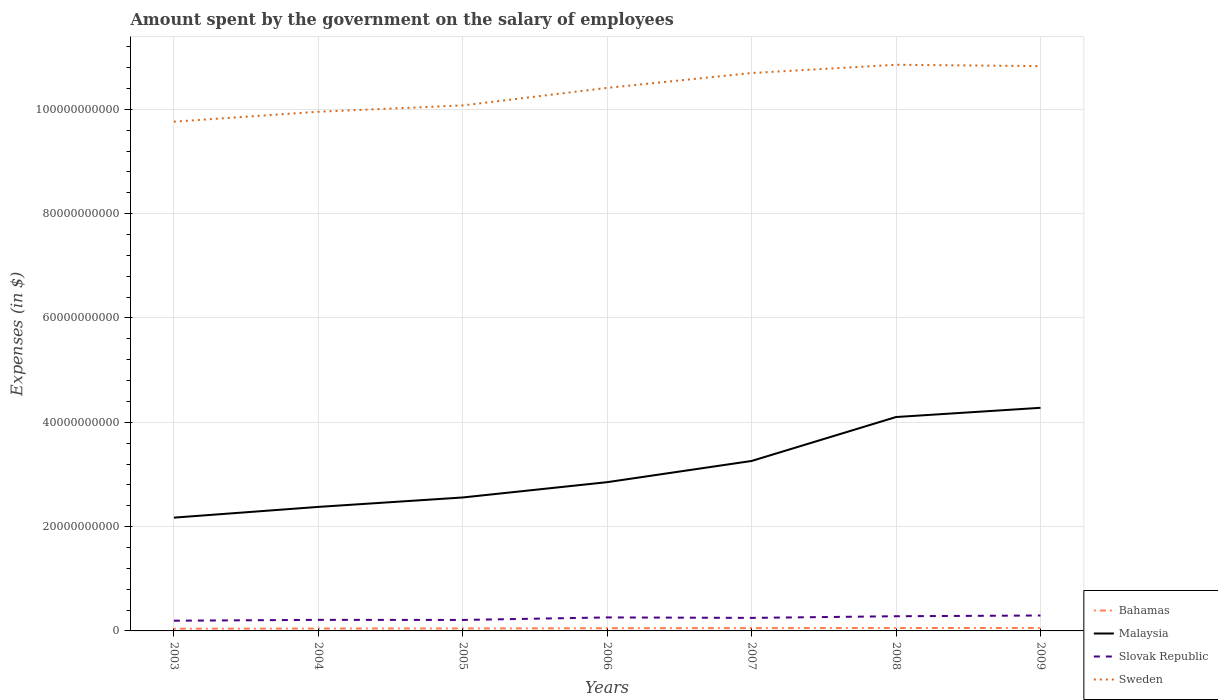How many different coloured lines are there?
Offer a terse response. 4. Does the line corresponding to Malaysia intersect with the line corresponding to Bahamas?
Your response must be concise. No. Is the number of lines equal to the number of legend labels?
Your answer should be very brief. Yes. Across all years, what is the maximum amount spent on the salary of employees by the government in Malaysia?
Keep it short and to the point. 2.17e+1. In which year was the amount spent on the salary of employees by the government in Slovak Republic maximum?
Provide a succinct answer. 2003. What is the total amount spent on the salary of employees by the government in Bahamas in the graph?
Offer a terse response. -2.32e+07. What is the difference between the highest and the second highest amount spent on the salary of employees by the government in Slovak Republic?
Provide a succinct answer. 9.97e+08. What is the difference between the highest and the lowest amount spent on the salary of employees by the government in Malaysia?
Your response must be concise. 3. How many lines are there?
Your answer should be very brief. 4. How many years are there in the graph?
Ensure brevity in your answer.  7. Does the graph contain any zero values?
Offer a very short reply. No. What is the title of the graph?
Offer a terse response. Amount spent by the government on the salary of employees. What is the label or title of the Y-axis?
Your response must be concise. Expenses (in $). What is the Expenses (in $) of Bahamas in 2003?
Give a very brief answer. 4.21e+08. What is the Expenses (in $) in Malaysia in 2003?
Offer a very short reply. 2.17e+1. What is the Expenses (in $) of Slovak Republic in 2003?
Ensure brevity in your answer.  1.96e+09. What is the Expenses (in $) of Sweden in 2003?
Give a very brief answer. 9.76e+1. What is the Expenses (in $) in Bahamas in 2004?
Offer a very short reply. 4.50e+08. What is the Expenses (in $) in Malaysia in 2004?
Offer a terse response. 2.38e+1. What is the Expenses (in $) of Slovak Republic in 2004?
Provide a succinct answer. 2.12e+09. What is the Expenses (in $) of Sweden in 2004?
Your answer should be very brief. 9.95e+1. What is the Expenses (in $) of Bahamas in 2005?
Your answer should be very brief. 4.70e+08. What is the Expenses (in $) in Malaysia in 2005?
Give a very brief answer. 2.56e+1. What is the Expenses (in $) of Slovak Republic in 2005?
Give a very brief answer. 2.10e+09. What is the Expenses (in $) in Sweden in 2005?
Your answer should be very brief. 1.01e+11. What is the Expenses (in $) of Bahamas in 2006?
Ensure brevity in your answer.  5.14e+08. What is the Expenses (in $) in Malaysia in 2006?
Offer a very short reply. 2.85e+1. What is the Expenses (in $) of Slovak Republic in 2006?
Provide a succinct answer. 2.59e+09. What is the Expenses (in $) in Sweden in 2006?
Keep it short and to the point. 1.04e+11. What is the Expenses (in $) in Bahamas in 2007?
Your answer should be very brief. 5.37e+08. What is the Expenses (in $) in Malaysia in 2007?
Provide a succinct answer. 3.26e+1. What is the Expenses (in $) in Slovak Republic in 2007?
Your answer should be compact. 2.50e+09. What is the Expenses (in $) in Sweden in 2007?
Make the answer very short. 1.07e+11. What is the Expenses (in $) in Bahamas in 2008?
Provide a succinct answer. 5.52e+08. What is the Expenses (in $) in Malaysia in 2008?
Make the answer very short. 4.10e+1. What is the Expenses (in $) in Slovak Republic in 2008?
Offer a terse response. 2.82e+09. What is the Expenses (in $) in Sweden in 2008?
Your response must be concise. 1.09e+11. What is the Expenses (in $) in Bahamas in 2009?
Give a very brief answer. 5.73e+08. What is the Expenses (in $) of Malaysia in 2009?
Offer a very short reply. 4.28e+1. What is the Expenses (in $) of Slovak Republic in 2009?
Make the answer very short. 2.96e+09. What is the Expenses (in $) in Sweden in 2009?
Ensure brevity in your answer.  1.08e+11. Across all years, what is the maximum Expenses (in $) in Bahamas?
Offer a very short reply. 5.73e+08. Across all years, what is the maximum Expenses (in $) of Malaysia?
Your answer should be compact. 4.28e+1. Across all years, what is the maximum Expenses (in $) in Slovak Republic?
Give a very brief answer. 2.96e+09. Across all years, what is the maximum Expenses (in $) of Sweden?
Offer a very short reply. 1.09e+11. Across all years, what is the minimum Expenses (in $) in Bahamas?
Ensure brevity in your answer.  4.21e+08. Across all years, what is the minimum Expenses (in $) of Malaysia?
Ensure brevity in your answer.  2.17e+1. Across all years, what is the minimum Expenses (in $) of Slovak Republic?
Provide a succinct answer. 1.96e+09. Across all years, what is the minimum Expenses (in $) of Sweden?
Offer a very short reply. 9.76e+1. What is the total Expenses (in $) of Bahamas in the graph?
Provide a short and direct response. 3.52e+09. What is the total Expenses (in $) in Malaysia in the graph?
Your answer should be very brief. 2.16e+11. What is the total Expenses (in $) in Slovak Republic in the graph?
Provide a succinct answer. 1.70e+1. What is the total Expenses (in $) in Sweden in the graph?
Make the answer very short. 7.26e+11. What is the difference between the Expenses (in $) of Bahamas in 2003 and that in 2004?
Provide a succinct answer. -2.88e+07. What is the difference between the Expenses (in $) in Malaysia in 2003 and that in 2004?
Offer a very short reply. -2.06e+09. What is the difference between the Expenses (in $) of Slovak Republic in 2003 and that in 2004?
Offer a terse response. -1.66e+08. What is the difference between the Expenses (in $) of Sweden in 2003 and that in 2004?
Keep it short and to the point. -1.91e+09. What is the difference between the Expenses (in $) in Bahamas in 2003 and that in 2005?
Provide a short and direct response. -4.88e+07. What is the difference between the Expenses (in $) in Malaysia in 2003 and that in 2005?
Provide a succinct answer. -3.87e+09. What is the difference between the Expenses (in $) of Slovak Republic in 2003 and that in 2005?
Give a very brief answer. -1.46e+08. What is the difference between the Expenses (in $) in Sweden in 2003 and that in 2005?
Make the answer very short. -3.12e+09. What is the difference between the Expenses (in $) of Bahamas in 2003 and that in 2006?
Give a very brief answer. -9.22e+07. What is the difference between the Expenses (in $) of Malaysia in 2003 and that in 2006?
Your response must be concise. -6.80e+09. What is the difference between the Expenses (in $) in Slovak Republic in 2003 and that in 2006?
Keep it short and to the point. -6.29e+08. What is the difference between the Expenses (in $) of Sweden in 2003 and that in 2006?
Your answer should be very brief. -6.48e+09. What is the difference between the Expenses (in $) of Bahamas in 2003 and that in 2007?
Offer a terse response. -1.15e+08. What is the difference between the Expenses (in $) in Malaysia in 2003 and that in 2007?
Offer a very short reply. -1.09e+1. What is the difference between the Expenses (in $) in Slovak Republic in 2003 and that in 2007?
Give a very brief answer. -5.42e+08. What is the difference between the Expenses (in $) in Sweden in 2003 and that in 2007?
Your answer should be very brief. -9.33e+09. What is the difference between the Expenses (in $) in Bahamas in 2003 and that in 2008?
Ensure brevity in your answer.  -1.31e+08. What is the difference between the Expenses (in $) in Malaysia in 2003 and that in 2008?
Provide a succinct answer. -1.93e+1. What is the difference between the Expenses (in $) in Slovak Republic in 2003 and that in 2008?
Provide a short and direct response. -8.58e+08. What is the difference between the Expenses (in $) in Sweden in 2003 and that in 2008?
Provide a succinct answer. -1.09e+1. What is the difference between the Expenses (in $) in Bahamas in 2003 and that in 2009?
Provide a succinct answer. -1.52e+08. What is the difference between the Expenses (in $) in Malaysia in 2003 and that in 2009?
Your answer should be very brief. -2.11e+1. What is the difference between the Expenses (in $) of Slovak Republic in 2003 and that in 2009?
Offer a terse response. -9.97e+08. What is the difference between the Expenses (in $) of Sweden in 2003 and that in 2009?
Provide a short and direct response. -1.06e+1. What is the difference between the Expenses (in $) of Bahamas in 2004 and that in 2005?
Offer a terse response. -2.00e+07. What is the difference between the Expenses (in $) in Malaysia in 2004 and that in 2005?
Provide a succinct answer. -1.81e+09. What is the difference between the Expenses (in $) in Slovak Republic in 2004 and that in 2005?
Your answer should be compact. 1.95e+07. What is the difference between the Expenses (in $) in Sweden in 2004 and that in 2005?
Offer a very short reply. -1.21e+09. What is the difference between the Expenses (in $) of Bahamas in 2004 and that in 2006?
Give a very brief answer. -6.34e+07. What is the difference between the Expenses (in $) of Malaysia in 2004 and that in 2006?
Give a very brief answer. -4.74e+09. What is the difference between the Expenses (in $) of Slovak Republic in 2004 and that in 2006?
Your response must be concise. -4.64e+08. What is the difference between the Expenses (in $) of Sweden in 2004 and that in 2006?
Make the answer very short. -4.57e+09. What is the difference between the Expenses (in $) of Bahamas in 2004 and that in 2007?
Ensure brevity in your answer.  -8.66e+07. What is the difference between the Expenses (in $) of Malaysia in 2004 and that in 2007?
Provide a short and direct response. -8.81e+09. What is the difference between the Expenses (in $) of Slovak Republic in 2004 and that in 2007?
Provide a short and direct response. -3.76e+08. What is the difference between the Expenses (in $) of Sweden in 2004 and that in 2007?
Your response must be concise. -7.42e+09. What is the difference between the Expenses (in $) of Bahamas in 2004 and that in 2008?
Make the answer very short. -1.02e+08. What is the difference between the Expenses (in $) of Malaysia in 2004 and that in 2008?
Your answer should be very brief. -1.72e+1. What is the difference between the Expenses (in $) of Slovak Republic in 2004 and that in 2008?
Make the answer very short. -6.92e+08. What is the difference between the Expenses (in $) in Sweden in 2004 and that in 2008?
Offer a terse response. -9.00e+09. What is the difference between the Expenses (in $) of Bahamas in 2004 and that in 2009?
Your answer should be very brief. -1.23e+08. What is the difference between the Expenses (in $) of Malaysia in 2004 and that in 2009?
Your answer should be compact. -1.90e+1. What is the difference between the Expenses (in $) of Slovak Republic in 2004 and that in 2009?
Ensure brevity in your answer.  -8.31e+08. What is the difference between the Expenses (in $) of Sweden in 2004 and that in 2009?
Offer a terse response. -8.74e+09. What is the difference between the Expenses (in $) of Bahamas in 2005 and that in 2006?
Your answer should be very brief. -4.34e+07. What is the difference between the Expenses (in $) in Malaysia in 2005 and that in 2006?
Provide a short and direct response. -2.93e+09. What is the difference between the Expenses (in $) in Slovak Republic in 2005 and that in 2006?
Give a very brief answer. -4.83e+08. What is the difference between the Expenses (in $) in Sweden in 2005 and that in 2006?
Provide a succinct answer. -3.36e+09. What is the difference between the Expenses (in $) in Bahamas in 2005 and that in 2007?
Your answer should be very brief. -6.66e+07. What is the difference between the Expenses (in $) in Malaysia in 2005 and that in 2007?
Give a very brief answer. -7.00e+09. What is the difference between the Expenses (in $) in Slovak Republic in 2005 and that in 2007?
Provide a succinct answer. -3.95e+08. What is the difference between the Expenses (in $) of Sweden in 2005 and that in 2007?
Keep it short and to the point. -6.21e+09. What is the difference between the Expenses (in $) of Bahamas in 2005 and that in 2008?
Your answer should be very brief. -8.19e+07. What is the difference between the Expenses (in $) in Malaysia in 2005 and that in 2008?
Give a very brief answer. -1.54e+1. What is the difference between the Expenses (in $) in Slovak Republic in 2005 and that in 2008?
Make the answer very short. -7.11e+08. What is the difference between the Expenses (in $) in Sweden in 2005 and that in 2008?
Provide a succinct answer. -7.79e+09. What is the difference between the Expenses (in $) in Bahamas in 2005 and that in 2009?
Your answer should be very brief. -1.03e+08. What is the difference between the Expenses (in $) of Malaysia in 2005 and that in 2009?
Offer a very short reply. -1.72e+1. What is the difference between the Expenses (in $) in Slovak Republic in 2005 and that in 2009?
Your response must be concise. -8.51e+08. What is the difference between the Expenses (in $) of Sweden in 2005 and that in 2009?
Your answer should be compact. -7.53e+09. What is the difference between the Expenses (in $) in Bahamas in 2006 and that in 2007?
Your response must be concise. -2.32e+07. What is the difference between the Expenses (in $) of Malaysia in 2006 and that in 2007?
Provide a short and direct response. -4.07e+09. What is the difference between the Expenses (in $) of Slovak Republic in 2006 and that in 2007?
Your response must be concise. 8.77e+07. What is the difference between the Expenses (in $) of Sweden in 2006 and that in 2007?
Provide a short and direct response. -2.85e+09. What is the difference between the Expenses (in $) in Bahamas in 2006 and that in 2008?
Your answer should be compact. -3.85e+07. What is the difference between the Expenses (in $) of Malaysia in 2006 and that in 2008?
Keep it short and to the point. -1.25e+1. What is the difference between the Expenses (in $) of Slovak Republic in 2006 and that in 2008?
Ensure brevity in your answer.  -2.28e+08. What is the difference between the Expenses (in $) in Sweden in 2006 and that in 2008?
Your answer should be compact. -4.43e+09. What is the difference between the Expenses (in $) in Bahamas in 2006 and that in 2009?
Provide a short and direct response. -5.96e+07. What is the difference between the Expenses (in $) of Malaysia in 2006 and that in 2009?
Provide a short and direct response. -1.43e+1. What is the difference between the Expenses (in $) of Slovak Republic in 2006 and that in 2009?
Keep it short and to the point. -3.68e+08. What is the difference between the Expenses (in $) of Sweden in 2006 and that in 2009?
Provide a short and direct response. -4.17e+09. What is the difference between the Expenses (in $) in Bahamas in 2007 and that in 2008?
Your response must be concise. -1.53e+07. What is the difference between the Expenses (in $) of Malaysia in 2007 and that in 2008?
Give a very brief answer. -8.42e+09. What is the difference between the Expenses (in $) in Slovak Republic in 2007 and that in 2008?
Your answer should be compact. -3.16e+08. What is the difference between the Expenses (in $) in Sweden in 2007 and that in 2008?
Provide a short and direct response. -1.58e+09. What is the difference between the Expenses (in $) in Bahamas in 2007 and that in 2009?
Provide a succinct answer. -3.64e+07. What is the difference between the Expenses (in $) of Malaysia in 2007 and that in 2009?
Your response must be concise. -1.02e+1. What is the difference between the Expenses (in $) in Slovak Republic in 2007 and that in 2009?
Your answer should be very brief. -4.55e+08. What is the difference between the Expenses (in $) of Sweden in 2007 and that in 2009?
Give a very brief answer. -1.32e+09. What is the difference between the Expenses (in $) in Bahamas in 2008 and that in 2009?
Ensure brevity in your answer.  -2.11e+07. What is the difference between the Expenses (in $) of Malaysia in 2008 and that in 2009?
Make the answer very short. -1.77e+09. What is the difference between the Expenses (in $) of Slovak Republic in 2008 and that in 2009?
Your response must be concise. -1.39e+08. What is the difference between the Expenses (in $) of Sweden in 2008 and that in 2009?
Ensure brevity in your answer.  2.59e+08. What is the difference between the Expenses (in $) of Bahamas in 2003 and the Expenses (in $) of Malaysia in 2004?
Ensure brevity in your answer.  -2.34e+1. What is the difference between the Expenses (in $) of Bahamas in 2003 and the Expenses (in $) of Slovak Republic in 2004?
Offer a very short reply. -1.70e+09. What is the difference between the Expenses (in $) in Bahamas in 2003 and the Expenses (in $) in Sweden in 2004?
Offer a very short reply. -9.91e+1. What is the difference between the Expenses (in $) in Malaysia in 2003 and the Expenses (in $) in Slovak Republic in 2004?
Ensure brevity in your answer.  1.96e+1. What is the difference between the Expenses (in $) of Malaysia in 2003 and the Expenses (in $) of Sweden in 2004?
Your answer should be very brief. -7.78e+1. What is the difference between the Expenses (in $) in Slovak Republic in 2003 and the Expenses (in $) in Sweden in 2004?
Ensure brevity in your answer.  -9.76e+1. What is the difference between the Expenses (in $) of Bahamas in 2003 and the Expenses (in $) of Malaysia in 2005?
Keep it short and to the point. -2.52e+1. What is the difference between the Expenses (in $) of Bahamas in 2003 and the Expenses (in $) of Slovak Republic in 2005?
Your response must be concise. -1.68e+09. What is the difference between the Expenses (in $) in Bahamas in 2003 and the Expenses (in $) in Sweden in 2005?
Provide a short and direct response. -1.00e+11. What is the difference between the Expenses (in $) in Malaysia in 2003 and the Expenses (in $) in Slovak Republic in 2005?
Keep it short and to the point. 1.96e+1. What is the difference between the Expenses (in $) of Malaysia in 2003 and the Expenses (in $) of Sweden in 2005?
Offer a terse response. -7.90e+1. What is the difference between the Expenses (in $) of Slovak Republic in 2003 and the Expenses (in $) of Sweden in 2005?
Offer a very short reply. -9.88e+1. What is the difference between the Expenses (in $) in Bahamas in 2003 and the Expenses (in $) in Malaysia in 2006?
Provide a succinct answer. -2.81e+1. What is the difference between the Expenses (in $) of Bahamas in 2003 and the Expenses (in $) of Slovak Republic in 2006?
Ensure brevity in your answer.  -2.17e+09. What is the difference between the Expenses (in $) of Bahamas in 2003 and the Expenses (in $) of Sweden in 2006?
Keep it short and to the point. -1.04e+11. What is the difference between the Expenses (in $) in Malaysia in 2003 and the Expenses (in $) in Slovak Republic in 2006?
Your answer should be very brief. 1.91e+1. What is the difference between the Expenses (in $) of Malaysia in 2003 and the Expenses (in $) of Sweden in 2006?
Offer a terse response. -8.24e+1. What is the difference between the Expenses (in $) of Slovak Republic in 2003 and the Expenses (in $) of Sweden in 2006?
Your answer should be compact. -1.02e+11. What is the difference between the Expenses (in $) in Bahamas in 2003 and the Expenses (in $) in Malaysia in 2007?
Offer a terse response. -3.22e+1. What is the difference between the Expenses (in $) in Bahamas in 2003 and the Expenses (in $) in Slovak Republic in 2007?
Offer a terse response. -2.08e+09. What is the difference between the Expenses (in $) of Bahamas in 2003 and the Expenses (in $) of Sweden in 2007?
Your answer should be compact. -1.07e+11. What is the difference between the Expenses (in $) of Malaysia in 2003 and the Expenses (in $) of Slovak Republic in 2007?
Provide a short and direct response. 1.92e+1. What is the difference between the Expenses (in $) of Malaysia in 2003 and the Expenses (in $) of Sweden in 2007?
Your answer should be compact. -8.52e+1. What is the difference between the Expenses (in $) of Slovak Republic in 2003 and the Expenses (in $) of Sweden in 2007?
Your answer should be compact. -1.05e+11. What is the difference between the Expenses (in $) in Bahamas in 2003 and the Expenses (in $) in Malaysia in 2008?
Make the answer very short. -4.06e+1. What is the difference between the Expenses (in $) in Bahamas in 2003 and the Expenses (in $) in Slovak Republic in 2008?
Your answer should be compact. -2.39e+09. What is the difference between the Expenses (in $) of Bahamas in 2003 and the Expenses (in $) of Sweden in 2008?
Keep it short and to the point. -1.08e+11. What is the difference between the Expenses (in $) of Malaysia in 2003 and the Expenses (in $) of Slovak Republic in 2008?
Your answer should be very brief. 1.89e+1. What is the difference between the Expenses (in $) of Malaysia in 2003 and the Expenses (in $) of Sweden in 2008?
Keep it short and to the point. -8.68e+1. What is the difference between the Expenses (in $) of Slovak Republic in 2003 and the Expenses (in $) of Sweden in 2008?
Your answer should be compact. -1.07e+11. What is the difference between the Expenses (in $) in Bahamas in 2003 and the Expenses (in $) in Malaysia in 2009?
Your answer should be very brief. -4.24e+1. What is the difference between the Expenses (in $) in Bahamas in 2003 and the Expenses (in $) in Slovak Republic in 2009?
Provide a succinct answer. -2.53e+09. What is the difference between the Expenses (in $) in Bahamas in 2003 and the Expenses (in $) in Sweden in 2009?
Offer a terse response. -1.08e+11. What is the difference between the Expenses (in $) of Malaysia in 2003 and the Expenses (in $) of Slovak Republic in 2009?
Make the answer very short. 1.88e+1. What is the difference between the Expenses (in $) in Malaysia in 2003 and the Expenses (in $) in Sweden in 2009?
Give a very brief answer. -8.66e+1. What is the difference between the Expenses (in $) in Slovak Republic in 2003 and the Expenses (in $) in Sweden in 2009?
Your answer should be very brief. -1.06e+11. What is the difference between the Expenses (in $) in Bahamas in 2004 and the Expenses (in $) in Malaysia in 2005?
Your answer should be compact. -2.51e+1. What is the difference between the Expenses (in $) in Bahamas in 2004 and the Expenses (in $) in Slovak Republic in 2005?
Give a very brief answer. -1.65e+09. What is the difference between the Expenses (in $) in Bahamas in 2004 and the Expenses (in $) in Sweden in 2005?
Make the answer very short. -1.00e+11. What is the difference between the Expenses (in $) of Malaysia in 2004 and the Expenses (in $) of Slovak Republic in 2005?
Your answer should be compact. 2.17e+1. What is the difference between the Expenses (in $) of Malaysia in 2004 and the Expenses (in $) of Sweden in 2005?
Offer a terse response. -7.70e+1. What is the difference between the Expenses (in $) of Slovak Republic in 2004 and the Expenses (in $) of Sweden in 2005?
Give a very brief answer. -9.86e+1. What is the difference between the Expenses (in $) in Bahamas in 2004 and the Expenses (in $) in Malaysia in 2006?
Offer a very short reply. -2.81e+1. What is the difference between the Expenses (in $) of Bahamas in 2004 and the Expenses (in $) of Slovak Republic in 2006?
Your answer should be compact. -2.14e+09. What is the difference between the Expenses (in $) in Bahamas in 2004 and the Expenses (in $) in Sweden in 2006?
Provide a succinct answer. -1.04e+11. What is the difference between the Expenses (in $) of Malaysia in 2004 and the Expenses (in $) of Slovak Republic in 2006?
Your answer should be compact. 2.12e+1. What is the difference between the Expenses (in $) in Malaysia in 2004 and the Expenses (in $) in Sweden in 2006?
Offer a very short reply. -8.03e+1. What is the difference between the Expenses (in $) of Slovak Republic in 2004 and the Expenses (in $) of Sweden in 2006?
Offer a terse response. -1.02e+11. What is the difference between the Expenses (in $) of Bahamas in 2004 and the Expenses (in $) of Malaysia in 2007?
Provide a succinct answer. -3.21e+1. What is the difference between the Expenses (in $) in Bahamas in 2004 and the Expenses (in $) in Slovak Republic in 2007?
Offer a very short reply. -2.05e+09. What is the difference between the Expenses (in $) in Bahamas in 2004 and the Expenses (in $) in Sweden in 2007?
Your answer should be very brief. -1.07e+11. What is the difference between the Expenses (in $) of Malaysia in 2004 and the Expenses (in $) of Slovak Republic in 2007?
Your answer should be compact. 2.13e+1. What is the difference between the Expenses (in $) of Malaysia in 2004 and the Expenses (in $) of Sweden in 2007?
Ensure brevity in your answer.  -8.32e+1. What is the difference between the Expenses (in $) of Slovak Republic in 2004 and the Expenses (in $) of Sweden in 2007?
Your answer should be very brief. -1.05e+11. What is the difference between the Expenses (in $) in Bahamas in 2004 and the Expenses (in $) in Malaysia in 2008?
Give a very brief answer. -4.06e+1. What is the difference between the Expenses (in $) of Bahamas in 2004 and the Expenses (in $) of Slovak Republic in 2008?
Provide a succinct answer. -2.37e+09. What is the difference between the Expenses (in $) of Bahamas in 2004 and the Expenses (in $) of Sweden in 2008?
Provide a short and direct response. -1.08e+11. What is the difference between the Expenses (in $) in Malaysia in 2004 and the Expenses (in $) in Slovak Republic in 2008?
Give a very brief answer. 2.10e+1. What is the difference between the Expenses (in $) in Malaysia in 2004 and the Expenses (in $) in Sweden in 2008?
Ensure brevity in your answer.  -8.48e+1. What is the difference between the Expenses (in $) in Slovak Republic in 2004 and the Expenses (in $) in Sweden in 2008?
Your response must be concise. -1.06e+11. What is the difference between the Expenses (in $) in Bahamas in 2004 and the Expenses (in $) in Malaysia in 2009?
Give a very brief answer. -4.23e+1. What is the difference between the Expenses (in $) of Bahamas in 2004 and the Expenses (in $) of Slovak Republic in 2009?
Your answer should be very brief. -2.50e+09. What is the difference between the Expenses (in $) in Bahamas in 2004 and the Expenses (in $) in Sweden in 2009?
Your response must be concise. -1.08e+11. What is the difference between the Expenses (in $) in Malaysia in 2004 and the Expenses (in $) in Slovak Republic in 2009?
Offer a terse response. 2.08e+1. What is the difference between the Expenses (in $) in Malaysia in 2004 and the Expenses (in $) in Sweden in 2009?
Your response must be concise. -8.45e+1. What is the difference between the Expenses (in $) of Slovak Republic in 2004 and the Expenses (in $) of Sweden in 2009?
Your response must be concise. -1.06e+11. What is the difference between the Expenses (in $) in Bahamas in 2005 and the Expenses (in $) in Malaysia in 2006?
Offer a terse response. -2.81e+1. What is the difference between the Expenses (in $) of Bahamas in 2005 and the Expenses (in $) of Slovak Republic in 2006?
Provide a succinct answer. -2.12e+09. What is the difference between the Expenses (in $) in Bahamas in 2005 and the Expenses (in $) in Sweden in 2006?
Offer a terse response. -1.04e+11. What is the difference between the Expenses (in $) in Malaysia in 2005 and the Expenses (in $) in Slovak Republic in 2006?
Your answer should be very brief. 2.30e+1. What is the difference between the Expenses (in $) of Malaysia in 2005 and the Expenses (in $) of Sweden in 2006?
Your answer should be very brief. -7.85e+1. What is the difference between the Expenses (in $) in Slovak Republic in 2005 and the Expenses (in $) in Sweden in 2006?
Your answer should be compact. -1.02e+11. What is the difference between the Expenses (in $) in Bahamas in 2005 and the Expenses (in $) in Malaysia in 2007?
Keep it short and to the point. -3.21e+1. What is the difference between the Expenses (in $) in Bahamas in 2005 and the Expenses (in $) in Slovak Republic in 2007?
Provide a succinct answer. -2.03e+09. What is the difference between the Expenses (in $) of Bahamas in 2005 and the Expenses (in $) of Sweden in 2007?
Your answer should be very brief. -1.06e+11. What is the difference between the Expenses (in $) of Malaysia in 2005 and the Expenses (in $) of Slovak Republic in 2007?
Your answer should be compact. 2.31e+1. What is the difference between the Expenses (in $) of Malaysia in 2005 and the Expenses (in $) of Sweden in 2007?
Your response must be concise. -8.14e+1. What is the difference between the Expenses (in $) of Slovak Republic in 2005 and the Expenses (in $) of Sweden in 2007?
Your answer should be compact. -1.05e+11. What is the difference between the Expenses (in $) of Bahamas in 2005 and the Expenses (in $) of Malaysia in 2008?
Keep it short and to the point. -4.05e+1. What is the difference between the Expenses (in $) of Bahamas in 2005 and the Expenses (in $) of Slovak Republic in 2008?
Offer a very short reply. -2.35e+09. What is the difference between the Expenses (in $) in Bahamas in 2005 and the Expenses (in $) in Sweden in 2008?
Your answer should be very brief. -1.08e+11. What is the difference between the Expenses (in $) in Malaysia in 2005 and the Expenses (in $) in Slovak Republic in 2008?
Make the answer very short. 2.28e+1. What is the difference between the Expenses (in $) of Malaysia in 2005 and the Expenses (in $) of Sweden in 2008?
Give a very brief answer. -8.30e+1. What is the difference between the Expenses (in $) in Slovak Republic in 2005 and the Expenses (in $) in Sweden in 2008?
Provide a short and direct response. -1.06e+11. What is the difference between the Expenses (in $) of Bahamas in 2005 and the Expenses (in $) of Malaysia in 2009?
Keep it short and to the point. -4.23e+1. What is the difference between the Expenses (in $) in Bahamas in 2005 and the Expenses (in $) in Slovak Republic in 2009?
Provide a short and direct response. -2.48e+09. What is the difference between the Expenses (in $) of Bahamas in 2005 and the Expenses (in $) of Sweden in 2009?
Keep it short and to the point. -1.08e+11. What is the difference between the Expenses (in $) in Malaysia in 2005 and the Expenses (in $) in Slovak Republic in 2009?
Your response must be concise. 2.26e+1. What is the difference between the Expenses (in $) in Malaysia in 2005 and the Expenses (in $) in Sweden in 2009?
Provide a short and direct response. -8.27e+1. What is the difference between the Expenses (in $) in Slovak Republic in 2005 and the Expenses (in $) in Sweden in 2009?
Give a very brief answer. -1.06e+11. What is the difference between the Expenses (in $) in Bahamas in 2006 and the Expenses (in $) in Malaysia in 2007?
Offer a terse response. -3.21e+1. What is the difference between the Expenses (in $) of Bahamas in 2006 and the Expenses (in $) of Slovak Republic in 2007?
Give a very brief answer. -1.99e+09. What is the difference between the Expenses (in $) of Bahamas in 2006 and the Expenses (in $) of Sweden in 2007?
Provide a succinct answer. -1.06e+11. What is the difference between the Expenses (in $) in Malaysia in 2006 and the Expenses (in $) in Slovak Republic in 2007?
Provide a succinct answer. 2.60e+1. What is the difference between the Expenses (in $) of Malaysia in 2006 and the Expenses (in $) of Sweden in 2007?
Keep it short and to the point. -7.84e+1. What is the difference between the Expenses (in $) in Slovak Republic in 2006 and the Expenses (in $) in Sweden in 2007?
Keep it short and to the point. -1.04e+11. What is the difference between the Expenses (in $) of Bahamas in 2006 and the Expenses (in $) of Malaysia in 2008?
Keep it short and to the point. -4.05e+1. What is the difference between the Expenses (in $) of Bahamas in 2006 and the Expenses (in $) of Slovak Republic in 2008?
Ensure brevity in your answer.  -2.30e+09. What is the difference between the Expenses (in $) in Bahamas in 2006 and the Expenses (in $) in Sweden in 2008?
Provide a succinct answer. -1.08e+11. What is the difference between the Expenses (in $) in Malaysia in 2006 and the Expenses (in $) in Slovak Republic in 2008?
Your answer should be compact. 2.57e+1. What is the difference between the Expenses (in $) of Malaysia in 2006 and the Expenses (in $) of Sweden in 2008?
Provide a succinct answer. -8.00e+1. What is the difference between the Expenses (in $) of Slovak Republic in 2006 and the Expenses (in $) of Sweden in 2008?
Your answer should be very brief. -1.06e+11. What is the difference between the Expenses (in $) in Bahamas in 2006 and the Expenses (in $) in Malaysia in 2009?
Keep it short and to the point. -4.23e+1. What is the difference between the Expenses (in $) of Bahamas in 2006 and the Expenses (in $) of Slovak Republic in 2009?
Provide a succinct answer. -2.44e+09. What is the difference between the Expenses (in $) of Bahamas in 2006 and the Expenses (in $) of Sweden in 2009?
Your answer should be compact. -1.08e+11. What is the difference between the Expenses (in $) in Malaysia in 2006 and the Expenses (in $) in Slovak Republic in 2009?
Ensure brevity in your answer.  2.56e+1. What is the difference between the Expenses (in $) in Malaysia in 2006 and the Expenses (in $) in Sweden in 2009?
Keep it short and to the point. -7.98e+1. What is the difference between the Expenses (in $) of Slovak Republic in 2006 and the Expenses (in $) of Sweden in 2009?
Offer a very short reply. -1.06e+11. What is the difference between the Expenses (in $) in Bahamas in 2007 and the Expenses (in $) in Malaysia in 2008?
Your answer should be very brief. -4.05e+1. What is the difference between the Expenses (in $) in Bahamas in 2007 and the Expenses (in $) in Slovak Republic in 2008?
Your answer should be very brief. -2.28e+09. What is the difference between the Expenses (in $) of Bahamas in 2007 and the Expenses (in $) of Sweden in 2008?
Your response must be concise. -1.08e+11. What is the difference between the Expenses (in $) in Malaysia in 2007 and the Expenses (in $) in Slovak Republic in 2008?
Make the answer very short. 2.98e+1. What is the difference between the Expenses (in $) of Malaysia in 2007 and the Expenses (in $) of Sweden in 2008?
Provide a succinct answer. -7.60e+1. What is the difference between the Expenses (in $) of Slovak Republic in 2007 and the Expenses (in $) of Sweden in 2008?
Offer a terse response. -1.06e+11. What is the difference between the Expenses (in $) of Bahamas in 2007 and the Expenses (in $) of Malaysia in 2009?
Make the answer very short. -4.22e+1. What is the difference between the Expenses (in $) in Bahamas in 2007 and the Expenses (in $) in Slovak Republic in 2009?
Keep it short and to the point. -2.42e+09. What is the difference between the Expenses (in $) in Bahamas in 2007 and the Expenses (in $) in Sweden in 2009?
Offer a terse response. -1.08e+11. What is the difference between the Expenses (in $) in Malaysia in 2007 and the Expenses (in $) in Slovak Republic in 2009?
Offer a terse response. 2.96e+1. What is the difference between the Expenses (in $) in Malaysia in 2007 and the Expenses (in $) in Sweden in 2009?
Offer a terse response. -7.57e+1. What is the difference between the Expenses (in $) in Slovak Republic in 2007 and the Expenses (in $) in Sweden in 2009?
Provide a succinct answer. -1.06e+11. What is the difference between the Expenses (in $) of Bahamas in 2008 and the Expenses (in $) of Malaysia in 2009?
Make the answer very short. -4.22e+1. What is the difference between the Expenses (in $) of Bahamas in 2008 and the Expenses (in $) of Slovak Republic in 2009?
Provide a short and direct response. -2.40e+09. What is the difference between the Expenses (in $) of Bahamas in 2008 and the Expenses (in $) of Sweden in 2009?
Offer a terse response. -1.08e+11. What is the difference between the Expenses (in $) of Malaysia in 2008 and the Expenses (in $) of Slovak Republic in 2009?
Provide a short and direct response. 3.81e+1. What is the difference between the Expenses (in $) of Malaysia in 2008 and the Expenses (in $) of Sweden in 2009?
Offer a very short reply. -6.73e+1. What is the difference between the Expenses (in $) in Slovak Republic in 2008 and the Expenses (in $) in Sweden in 2009?
Your response must be concise. -1.05e+11. What is the average Expenses (in $) in Bahamas per year?
Make the answer very short. 5.02e+08. What is the average Expenses (in $) in Malaysia per year?
Provide a succinct answer. 3.09e+1. What is the average Expenses (in $) in Slovak Republic per year?
Ensure brevity in your answer.  2.43e+09. What is the average Expenses (in $) of Sweden per year?
Keep it short and to the point. 1.04e+11. In the year 2003, what is the difference between the Expenses (in $) in Bahamas and Expenses (in $) in Malaysia?
Ensure brevity in your answer.  -2.13e+1. In the year 2003, what is the difference between the Expenses (in $) in Bahamas and Expenses (in $) in Slovak Republic?
Your answer should be very brief. -1.54e+09. In the year 2003, what is the difference between the Expenses (in $) in Bahamas and Expenses (in $) in Sweden?
Offer a terse response. -9.72e+1. In the year 2003, what is the difference between the Expenses (in $) of Malaysia and Expenses (in $) of Slovak Republic?
Your answer should be very brief. 1.98e+1. In the year 2003, what is the difference between the Expenses (in $) in Malaysia and Expenses (in $) in Sweden?
Offer a terse response. -7.59e+1. In the year 2003, what is the difference between the Expenses (in $) in Slovak Republic and Expenses (in $) in Sweden?
Offer a very short reply. -9.57e+1. In the year 2004, what is the difference between the Expenses (in $) of Bahamas and Expenses (in $) of Malaysia?
Ensure brevity in your answer.  -2.33e+1. In the year 2004, what is the difference between the Expenses (in $) of Bahamas and Expenses (in $) of Slovak Republic?
Offer a very short reply. -1.67e+09. In the year 2004, what is the difference between the Expenses (in $) of Bahamas and Expenses (in $) of Sweden?
Provide a short and direct response. -9.91e+1. In the year 2004, what is the difference between the Expenses (in $) of Malaysia and Expenses (in $) of Slovak Republic?
Give a very brief answer. 2.17e+1. In the year 2004, what is the difference between the Expenses (in $) in Malaysia and Expenses (in $) in Sweden?
Make the answer very short. -7.58e+1. In the year 2004, what is the difference between the Expenses (in $) of Slovak Republic and Expenses (in $) of Sweden?
Your response must be concise. -9.74e+1. In the year 2005, what is the difference between the Expenses (in $) of Bahamas and Expenses (in $) of Malaysia?
Your answer should be compact. -2.51e+1. In the year 2005, what is the difference between the Expenses (in $) in Bahamas and Expenses (in $) in Slovak Republic?
Your response must be concise. -1.63e+09. In the year 2005, what is the difference between the Expenses (in $) in Bahamas and Expenses (in $) in Sweden?
Give a very brief answer. -1.00e+11. In the year 2005, what is the difference between the Expenses (in $) in Malaysia and Expenses (in $) in Slovak Republic?
Your answer should be very brief. 2.35e+1. In the year 2005, what is the difference between the Expenses (in $) of Malaysia and Expenses (in $) of Sweden?
Provide a short and direct response. -7.52e+1. In the year 2005, what is the difference between the Expenses (in $) of Slovak Republic and Expenses (in $) of Sweden?
Your answer should be very brief. -9.87e+1. In the year 2006, what is the difference between the Expenses (in $) in Bahamas and Expenses (in $) in Malaysia?
Your answer should be compact. -2.80e+1. In the year 2006, what is the difference between the Expenses (in $) in Bahamas and Expenses (in $) in Slovak Republic?
Provide a short and direct response. -2.07e+09. In the year 2006, what is the difference between the Expenses (in $) in Bahamas and Expenses (in $) in Sweden?
Offer a terse response. -1.04e+11. In the year 2006, what is the difference between the Expenses (in $) of Malaysia and Expenses (in $) of Slovak Republic?
Offer a terse response. 2.59e+1. In the year 2006, what is the difference between the Expenses (in $) in Malaysia and Expenses (in $) in Sweden?
Make the answer very short. -7.56e+1. In the year 2006, what is the difference between the Expenses (in $) in Slovak Republic and Expenses (in $) in Sweden?
Keep it short and to the point. -1.02e+11. In the year 2007, what is the difference between the Expenses (in $) of Bahamas and Expenses (in $) of Malaysia?
Your answer should be compact. -3.21e+1. In the year 2007, what is the difference between the Expenses (in $) in Bahamas and Expenses (in $) in Slovak Republic?
Your answer should be compact. -1.96e+09. In the year 2007, what is the difference between the Expenses (in $) in Bahamas and Expenses (in $) in Sweden?
Your response must be concise. -1.06e+11. In the year 2007, what is the difference between the Expenses (in $) in Malaysia and Expenses (in $) in Slovak Republic?
Ensure brevity in your answer.  3.01e+1. In the year 2007, what is the difference between the Expenses (in $) in Malaysia and Expenses (in $) in Sweden?
Make the answer very short. -7.44e+1. In the year 2007, what is the difference between the Expenses (in $) of Slovak Republic and Expenses (in $) of Sweden?
Give a very brief answer. -1.04e+11. In the year 2008, what is the difference between the Expenses (in $) of Bahamas and Expenses (in $) of Malaysia?
Provide a succinct answer. -4.05e+1. In the year 2008, what is the difference between the Expenses (in $) in Bahamas and Expenses (in $) in Slovak Republic?
Make the answer very short. -2.26e+09. In the year 2008, what is the difference between the Expenses (in $) of Bahamas and Expenses (in $) of Sweden?
Your response must be concise. -1.08e+11. In the year 2008, what is the difference between the Expenses (in $) in Malaysia and Expenses (in $) in Slovak Republic?
Offer a very short reply. 3.82e+1. In the year 2008, what is the difference between the Expenses (in $) in Malaysia and Expenses (in $) in Sweden?
Provide a succinct answer. -6.75e+1. In the year 2008, what is the difference between the Expenses (in $) of Slovak Republic and Expenses (in $) of Sweden?
Provide a succinct answer. -1.06e+11. In the year 2009, what is the difference between the Expenses (in $) of Bahamas and Expenses (in $) of Malaysia?
Keep it short and to the point. -4.22e+1. In the year 2009, what is the difference between the Expenses (in $) of Bahamas and Expenses (in $) of Slovak Republic?
Offer a very short reply. -2.38e+09. In the year 2009, what is the difference between the Expenses (in $) in Bahamas and Expenses (in $) in Sweden?
Keep it short and to the point. -1.08e+11. In the year 2009, what is the difference between the Expenses (in $) of Malaysia and Expenses (in $) of Slovak Republic?
Provide a short and direct response. 3.98e+1. In the year 2009, what is the difference between the Expenses (in $) of Malaysia and Expenses (in $) of Sweden?
Give a very brief answer. -6.55e+1. In the year 2009, what is the difference between the Expenses (in $) of Slovak Republic and Expenses (in $) of Sweden?
Give a very brief answer. -1.05e+11. What is the ratio of the Expenses (in $) in Bahamas in 2003 to that in 2004?
Offer a very short reply. 0.94. What is the ratio of the Expenses (in $) of Malaysia in 2003 to that in 2004?
Your response must be concise. 0.91. What is the ratio of the Expenses (in $) in Slovak Republic in 2003 to that in 2004?
Your answer should be compact. 0.92. What is the ratio of the Expenses (in $) of Sweden in 2003 to that in 2004?
Offer a terse response. 0.98. What is the ratio of the Expenses (in $) of Bahamas in 2003 to that in 2005?
Your answer should be compact. 0.9. What is the ratio of the Expenses (in $) in Malaysia in 2003 to that in 2005?
Offer a very short reply. 0.85. What is the ratio of the Expenses (in $) in Slovak Republic in 2003 to that in 2005?
Your answer should be compact. 0.93. What is the ratio of the Expenses (in $) of Sweden in 2003 to that in 2005?
Give a very brief answer. 0.97. What is the ratio of the Expenses (in $) of Bahamas in 2003 to that in 2006?
Offer a very short reply. 0.82. What is the ratio of the Expenses (in $) in Malaysia in 2003 to that in 2006?
Offer a very short reply. 0.76. What is the ratio of the Expenses (in $) of Slovak Republic in 2003 to that in 2006?
Make the answer very short. 0.76. What is the ratio of the Expenses (in $) in Sweden in 2003 to that in 2006?
Offer a very short reply. 0.94. What is the ratio of the Expenses (in $) of Bahamas in 2003 to that in 2007?
Your answer should be compact. 0.79. What is the ratio of the Expenses (in $) in Malaysia in 2003 to that in 2007?
Keep it short and to the point. 0.67. What is the ratio of the Expenses (in $) of Slovak Republic in 2003 to that in 2007?
Make the answer very short. 0.78. What is the ratio of the Expenses (in $) in Sweden in 2003 to that in 2007?
Ensure brevity in your answer.  0.91. What is the ratio of the Expenses (in $) of Bahamas in 2003 to that in 2008?
Your answer should be compact. 0.76. What is the ratio of the Expenses (in $) of Malaysia in 2003 to that in 2008?
Your answer should be compact. 0.53. What is the ratio of the Expenses (in $) of Slovak Republic in 2003 to that in 2008?
Keep it short and to the point. 0.7. What is the ratio of the Expenses (in $) of Sweden in 2003 to that in 2008?
Give a very brief answer. 0.9. What is the ratio of the Expenses (in $) in Bahamas in 2003 to that in 2009?
Your answer should be compact. 0.74. What is the ratio of the Expenses (in $) of Malaysia in 2003 to that in 2009?
Offer a very short reply. 0.51. What is the ratio of the Expenses (in $) of Slovak Republic in 2003 to that in 2009?
Ensure brevity in your answer.  0.66. What is the ratio of the Expenses (in $) of Sweden in 2003 to that in 2009?
Provide a succinct answer. 0.9. What is the ratio of the Expenses (in $) in Bahamas in 2004 to that in 2005?
Your response must be concise. 0.96. What is the ratio of the Expenses (in $) in Malaysia in 2004 to that in 2005?
Your answer should be very brief. 0.93. What is the ratio of the Expenses (in $) in Slovak Republic in 2004 to that in 2005?
Keep it short and to the point. 1.01. What is the ratio of the Expenses (in $) of Bahamas in 2004 to that in 2006?
Your answer should be compact. 0.88. What is the ratio of the Expenses (in $) in Malaysia in 2004 to that in 2006?
Offer a very short reply. 0.83. What is the ratio of the Expenses (in $) in Slovak Republic in 2004 to that in 2006?
Ensure brevity in your answer.  0.82. What is the ratio of the Expenses (in $) in Sweden in 2004 to that in 2006?
Give a very brief answer. 0.96. What is the ratio of the Expenses (in $) of Bahamas in 2004 to that in 2007?
Make the answer very short. 0.84. What is the ratio of the Expenses (in $) in Malaysia in 2004 to that in 2007?
Offer a very short reply. 0.73. What is the ratio of the Expenses (in $) of Slovak Republic in 2004 to that in 2007?
Your answer should be compact. 0.85. What is the ratio of the Expenses (in $) in Sweden in 2004 to that in 2007?
Your response must be concise. 0.93. What is the ratio of the Expenses (in $) of Bahamas in 2004 to that in 2008?
Make the answer very short. 0.82. What is the ratio of the Expenses (in $) in Malaysia in 2004 to that in 2008?
Keep it short and to the point. 0.58. What is the ratio of the Expenses (in $) in Slovak Republic in 2004 to that in 2008?
Ensure brevity in your answer.  0.75. What is the ratio of the Expenses (in $) of Sweden in 2004 to that in 2008?
Keep it short and to the point. 0.92. What is the ratio of the Expenses (in $) of Bahamas in 2004 to that in 2009?
Your answer should be very brief. 0.79. What is the ratio of the Expenses (in $) of Malaysia in 2004 to that in 2009?
Provide a succinct answer. 0.56. What is the ratio of the Expenses (in $) of Slovak Republic in 2004 to that in 2009?
Offer a very short reply. 0.72. What is the ratio of the Expenses (in $) of Sweden in 2004 to that in 2009?
Offer a terse response. 0.92. What is the ratio of the Expenses (in $) of Bahamas in 2005 to that in 2006?
Provide a succinct answer. 0.92. What is the ratio of the Expenses (in $) in Malaysia in 2005 to that in 2006?
Provide a short and direct response. 0.9. What is the ratio of the Expenses (in $) in Slovak Republic in 2005 to that in 2006?
Keep it short and to the point. 0.81. What is the ratio of the Expenses (in $) of Sweden in 2005 to that in 2006?
Keep it short and to the point. 0.97. What is the ratio of the Expenses (in $) of Bahamas in 2005 to that in 2007?
Offer a terse response. 0.88. What is the ratio of the Expenses (in $) of Malaysia in 2005 to that in 2007?
Keep it short and to the point. 0.79. What is the ratio of the Expenses (in $) of Slovak Republic in 2005 to that in 2007?
Ensure brevity in your answer.  0.84. What is the ratio of the Expenses (in $) of Sweden in 2005 to that in 2007?
Your answer should be compact. 0.94. What is the ratio of the Expenses (in $) of Bahamas in 2005 to that in 2008?
Ensure brevity in your answer.  0.85. What is the ratio of the Expenses (in $) of Malaysia in 2005 to that in 2008?
Give a very brief answer. 0.62. What is the ratio of the Expenses (in $) of Slovak Republic in 2005 to that in 2008?
Offer a very short reply. 0.75. What is the ratio of the Expenses (in $) of Sweden in 2005 to that in 2008?
Your answer should be very brief. 0.93. What is the ratio of the Expenses (in $) of Bahamas in 2005 to that in 2009?
Your answer should be compact. 0.82. What is the ratio of the Expenses (in $) of Malaysia in 2005 to that in 2009?
Make the answer very short. 0.6. What is the ratio of the Expenses (in $) of Slovak Republic in 2005 to that in 2009?
Your answer should be compact. 0.71. What is the ratio of the Expenses (in $) in Sweden in 2005 to that in 2009?
Your response must be concise. 0.93. What is the ratio of the Expenses (in $) of Bahamas in 2006 to that in 2007?
Keep it short and to the point. 0.96. What is the ratio of the Expenses (in $) of Malaysia in 2006 to that in 2007?
Your response must be concise. 0.88. What is the ratio of the Expenses (in $) in Slovak Republic in 2006 to that in 2007?
Offer a terse response. 1.04. What is the ratio of the Expenses (in $) of Sweden in 2006 to that in 2007?
Provide a short and direct response. 0.97. What is the ratio of the Expenses (in $) of Bahamas in 2006 to that in 2008?
Your answer should be compact. 0.93. What is the ratio of the Expenses (in $) in Malaysia in 2006 to that in 2008?
Provide a short and direct response. 0.7. What is the ratio of the Expenses (in $) of Slovak Republic in 2006 to that in 2008?
Make the answer very short. 0.92. What is the ratio of the Expenses (in $) in Sweden in 2006 to that in 2008?
Offer a terse response. 0.96. What is the ratio of the Expenses (in $) in Bahamas in 2006 to that in 2009?
Keep it short and to the point. 0.9. What is the ratio of the Expenses (in $) of Slovak Republic in 2006 to that in 2009?
Make the answer very short. 0.88. What is the ratio of the Expenses (in $) in Sweden in 2006 to that in 2009?
Your answer should be very brief. 0.96. What is the ratio of the Expenses (in $) of Bahamas in 2007 to that in 2008?
Give a very brief answer. 0.97. What is the ratio of the Expenses (in $) in Malaysia in 2007 to that in 2008?
Your answer should be compact. 0.79. What is the ratio of the Expenses (in $) in Slovak Republic in 2007 to that in 2008?
Provide a succinct answer. 0.89. What is the ratio of the Expenses (in $) of Sweden in 2007 to that in 2008?
Give a very brief answer. 0.99. What is the ratio of the Expenses (in $) of Bahamas in 2007 to that in 2009?
Keep it short and to the point. 0.94. What is the ratio of the Expenses (in $) in Malaysia in 2007 to that in 2009?
Ensure brevity in your answer.  0.76. What is the ratio of the Expenses (in $) in Slovak Republic in 2007 to that in 2009?
Offer a terse response. 0.85. What is the ratio of the Expenses (in $) of Bahamas in 2008 to that in 2009?
Offer a terse response. 0.96. What is the ratio of the Expenses (in $) of Malaysia in 2008 to that in 2009?
Make the answer very short. 0.96. What is the ratio of the Expenses (in $) in Slovak Republic in 2008 to that in 2009?
Offer a terse response. 0.95. What is the ratio of the Expenses (in $) in Sweden in 2008 to that in 2009?
Your response must be concise. 1. What is the difference between the highest and the second highest Expenses (in $) of Bahamas?
Provide a succinct answer. 2.11e+07. What is the difference between the highest and the second highest Expenses (in $) in Malaysia?
Ensure brevity in your answer.  1.77e+09. What is the difference between the highest and the second highest Expenses (in $) in Slovak Republic?
Your response must be concise. 1.39e+08. What is the difference between the highest and the second highest Expenses (in $) of Sweden?
Provide a succinct answer. 2.59e+08. What is the difference between the highest and the lowest Expenses (in $) in Bahamas?
Provide a succinct answer. 1.52e+08. What is the difference between the highest and the lowest Expenses (in $) of Malaysia?
Provide a short and direct response. 2.11e+1. What is the difference between the highest and the lowest Expenses (in $) of Slovak Republic?
Provide a short and direct response. 9.97e+08. What is the difference between the highest and the lowest Expenses (in $) in Sweden?
Your answer should be compact. 1.09e+1. 